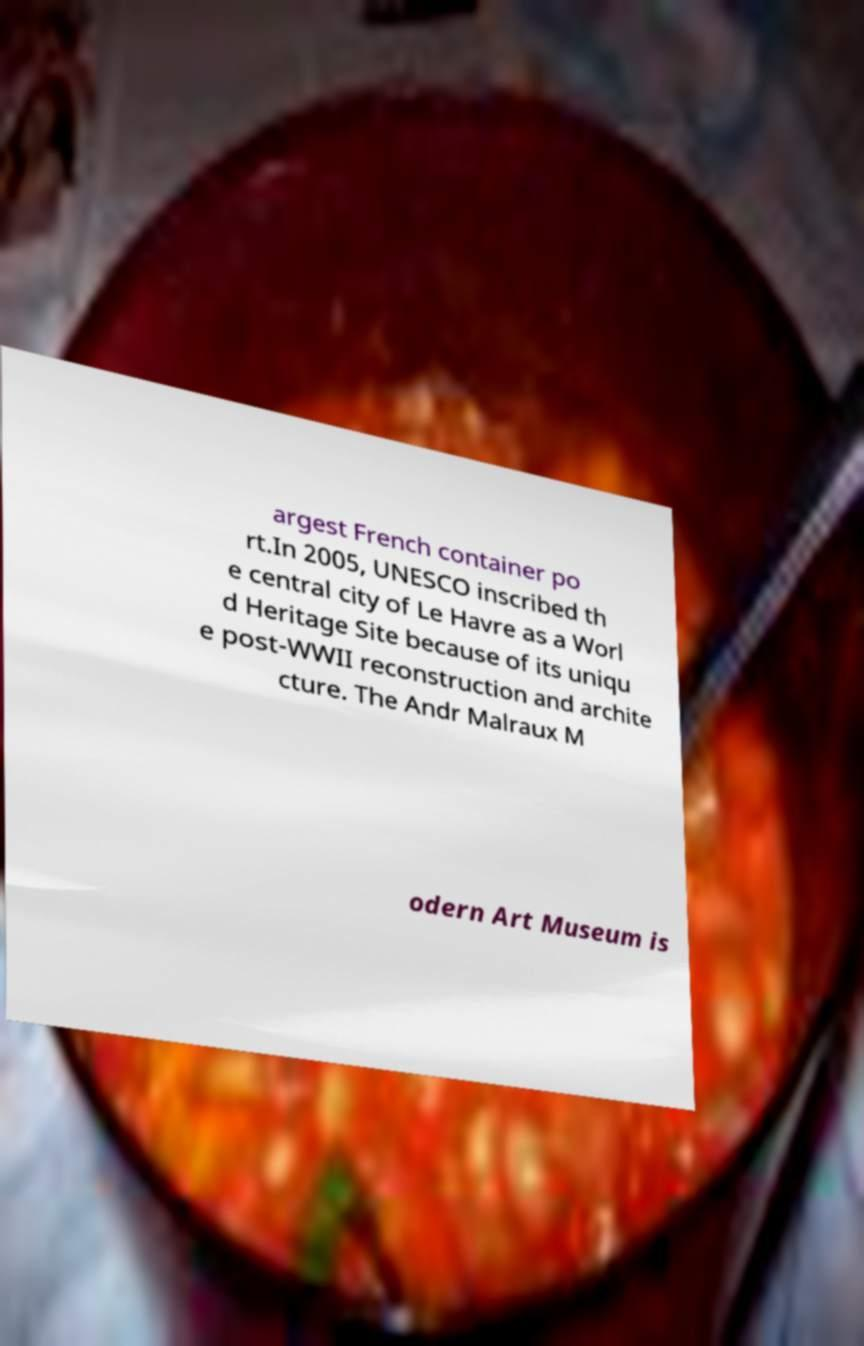Can you accurately transcribe the text from the provided image for me? argest French container po rt.In 2005, UNESCO inscribed th e central city of Le Havre as a Worl d Heritage Site because of its uniqu e post-WWII reconstruction and archite cture. The Andr Malraux M odern Art Museum is 